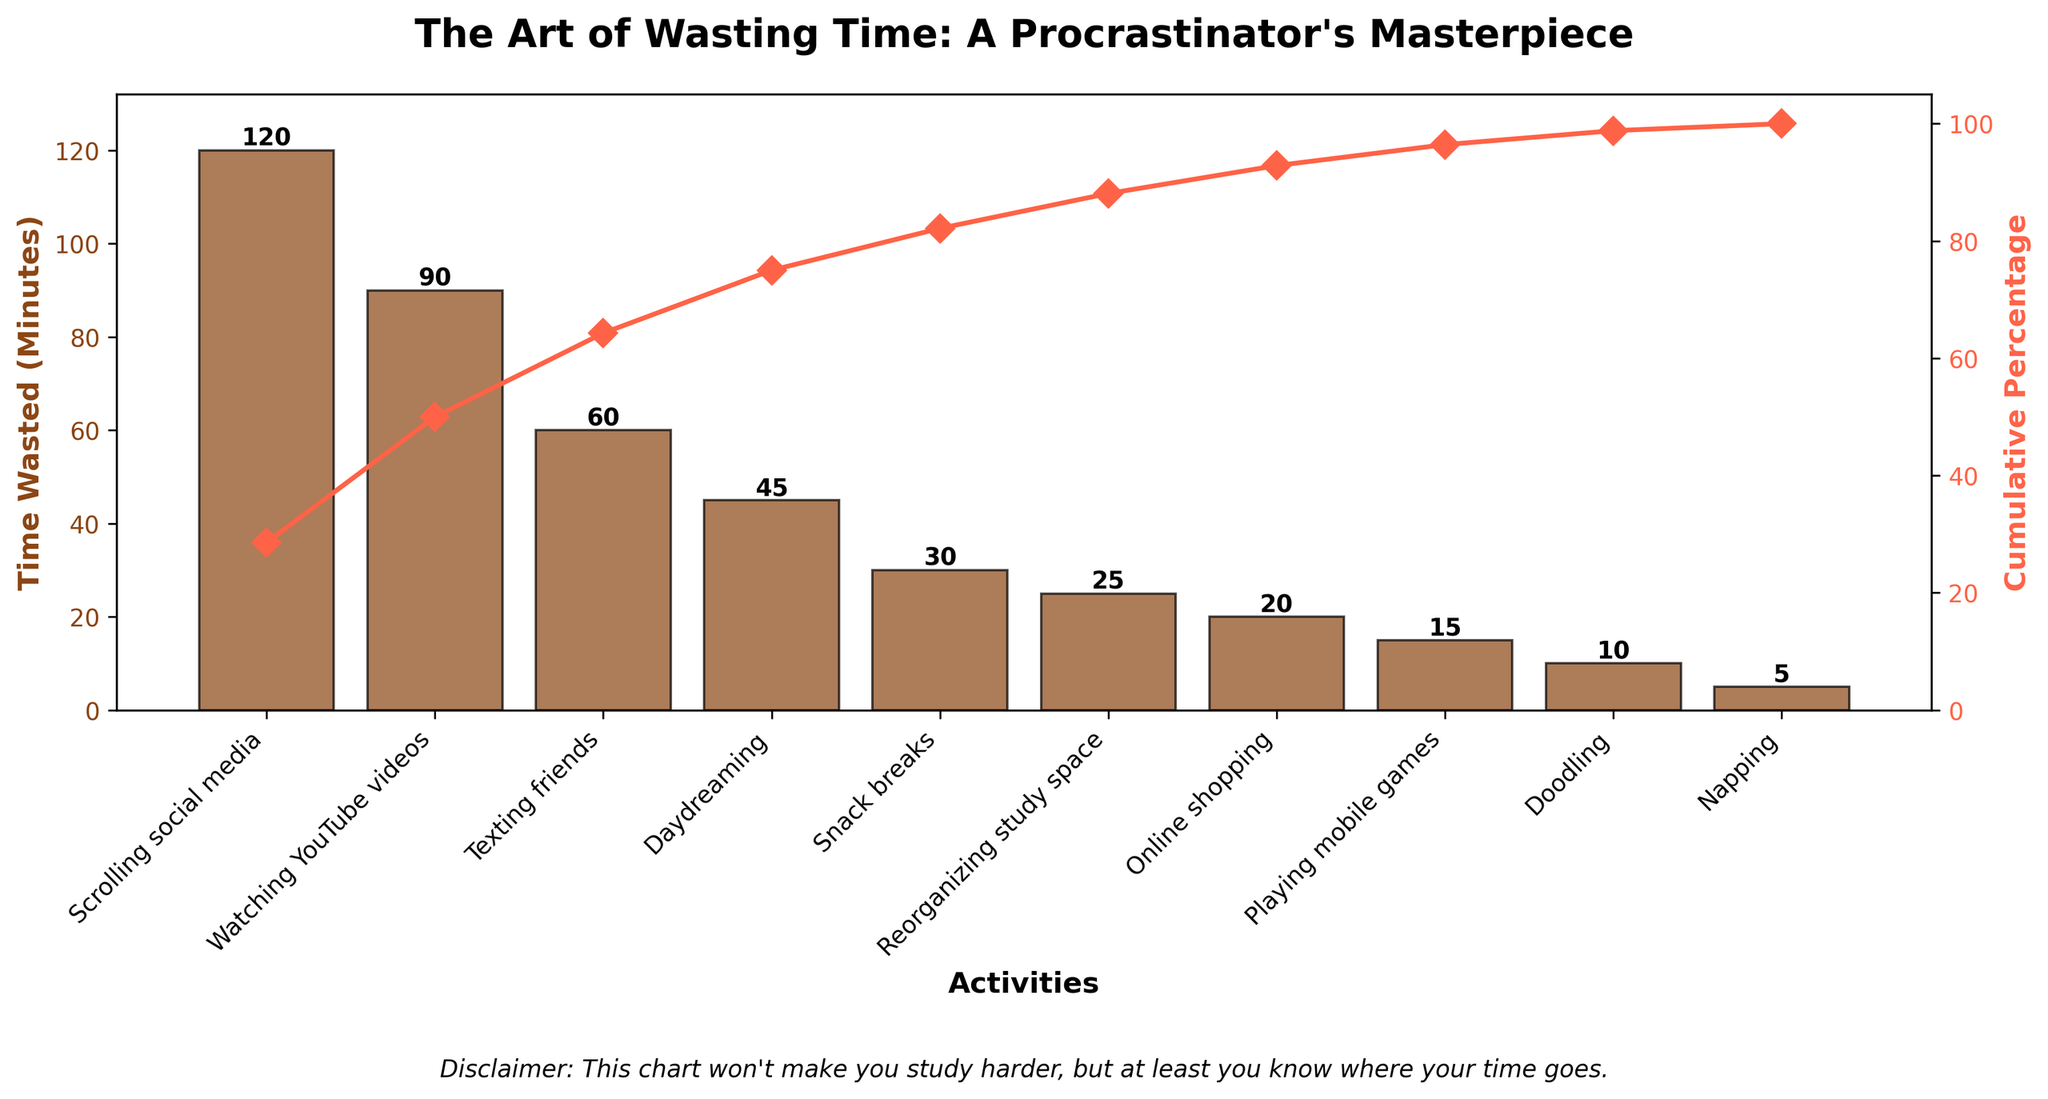What is the title of the figure? The title is typically located at the top and provides a summary of the figure's content. In this figure, it emphasizes time-wasting activities with a hint of sarcasm.
Answer: "The Art of Wasting Time: A Procrastinator's Masterpiece" What activity wastes the most time? The tallest bar in the bar plot represents the activity that wastes the most time. Here, it's the first bar on the left.
Answer: Scrolling social media What's the cumulative percentage for "Texting friends"? To find this, look at the line plot for the activity "Texting friends" and locate its point on the y-axis representing the cumulative percentage.
Answer: 75% Which activities take up less than 20 minutes? Identify the bars that have heights less than 20 on the y-axis. They are the shortest bars on the right side.
Answer: Online shopping, Playing mobile games, Doodling, Napping How much time is wasted on "Watching YouTube videos" and "Texting friends" combined? Add the values of the bars corresponding to these two activities. Watching YouTube videos: 90 minutes, Texting friends: 60 minutes.
Answer: 150 minutes What activity has the highest cumulative percentage on its own? Find the point on the line plot that is highest and check which bar it aligns with. Usually, it will be the last activity.
Answer: Scrolling social media What are the cumulative percentages for "Reorganizing study space" and "Online shopping"? Look at the points on the line plot for these activities and note their y-axis values. Reorganizing study space: 92.5%, Online shopping: 98.3%.
Answer: 92.5%, 98.3% Which activity justifies your snack breaks, given its lower time wastage? Identify the activity with a reasonable bar height but not the lowest, typically towards the middle of the chart.
Answer: Snack breaks How many total minutes are wasted on the three least time-consuming activities? Sum the minutes of the three shortest bars on the right. Online shopping: 20 minutes, Playing mobile games: 15 minutes, Doodling: 10 minutes.
Answer: 45 minutes 